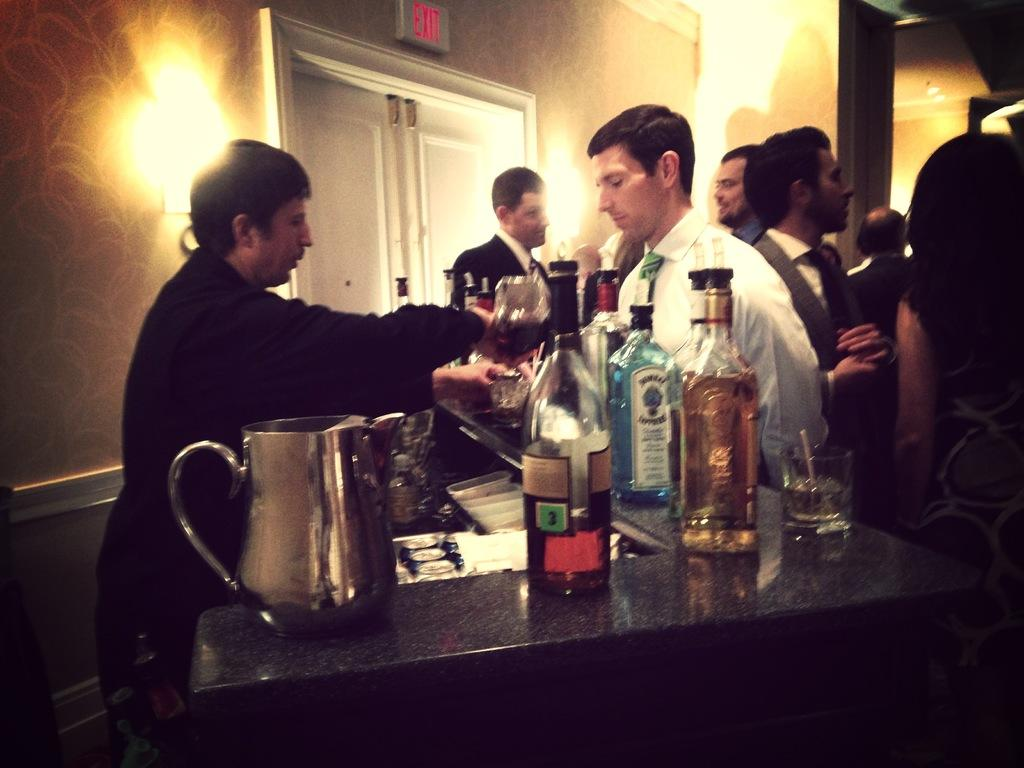<image>
Offer a succinct explanation of the picture presented. A bottle of alcohol on a bar has a green square with the number 3 on it. 